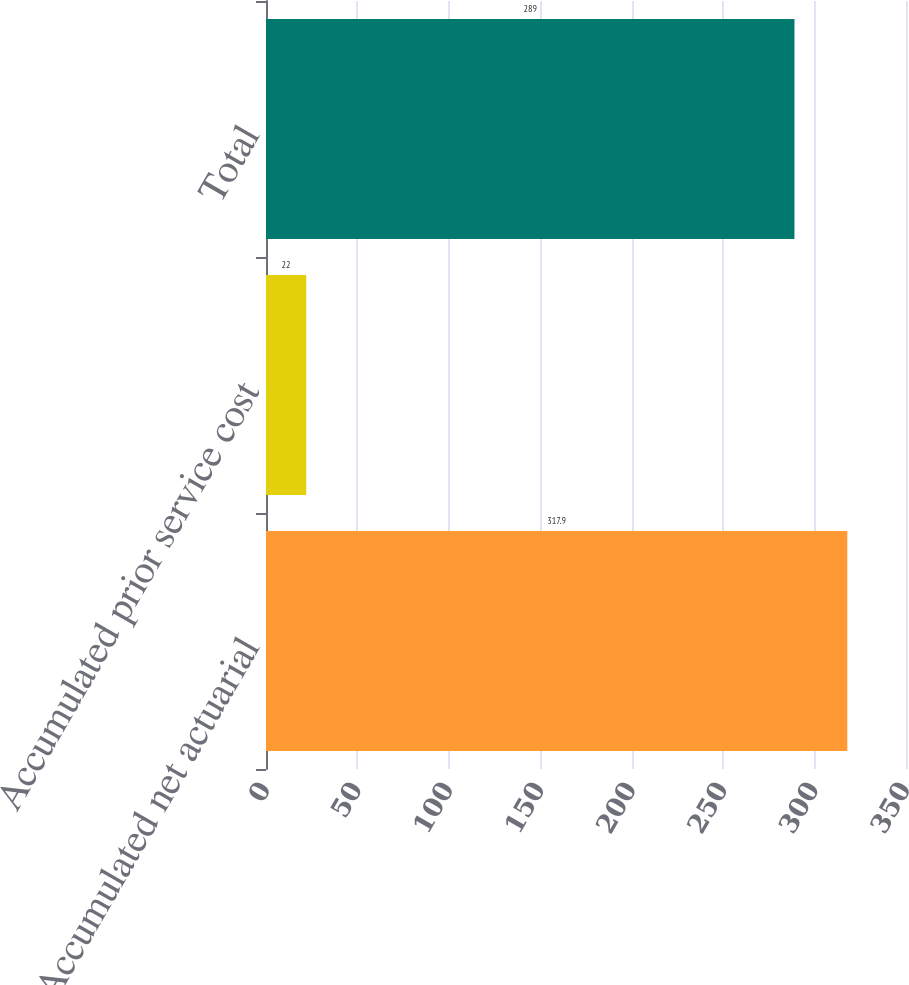Convert chart to OTSL. <chart><loc_0><loc_0><loc_500><loc_500><bar_chart><fcel>Accumulated net actuarial<fcel>Accumulated prior service cost<fcel>Total<nl><fcel>317.9<fcel>22<fcel>289<nl></chart> 